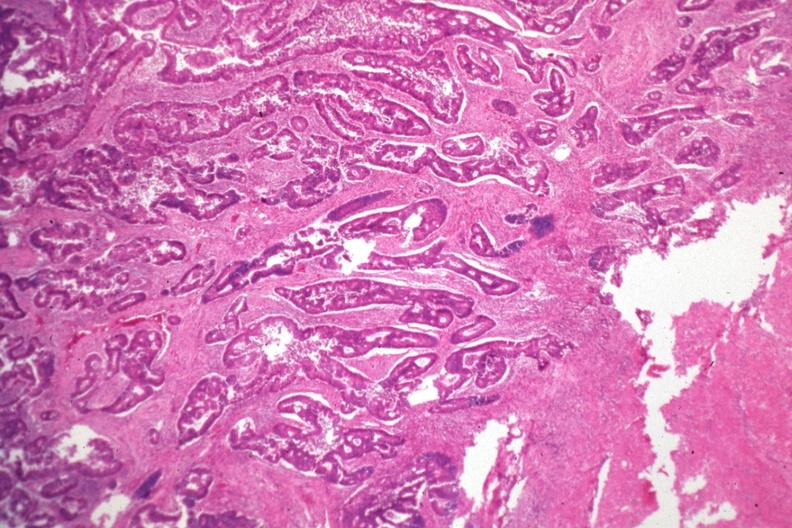what is present?
Answer the question using a single word or phrase. Colon 